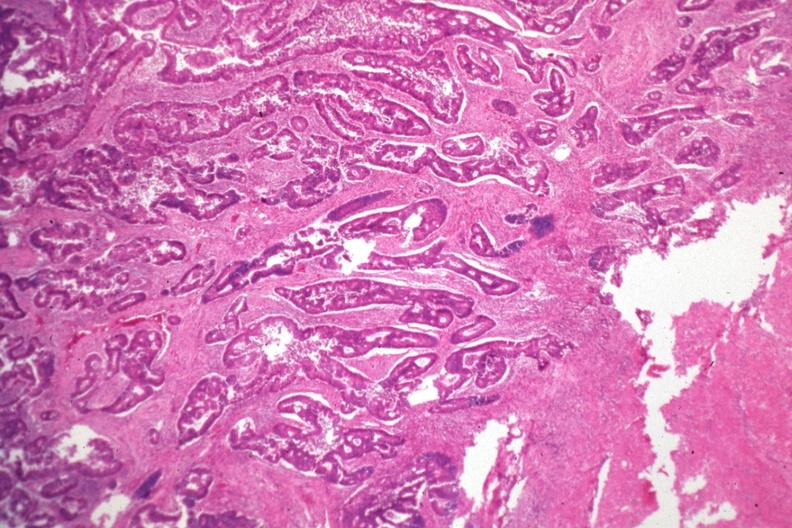what is present?
Answer the question using a single word or phrase. Colon 